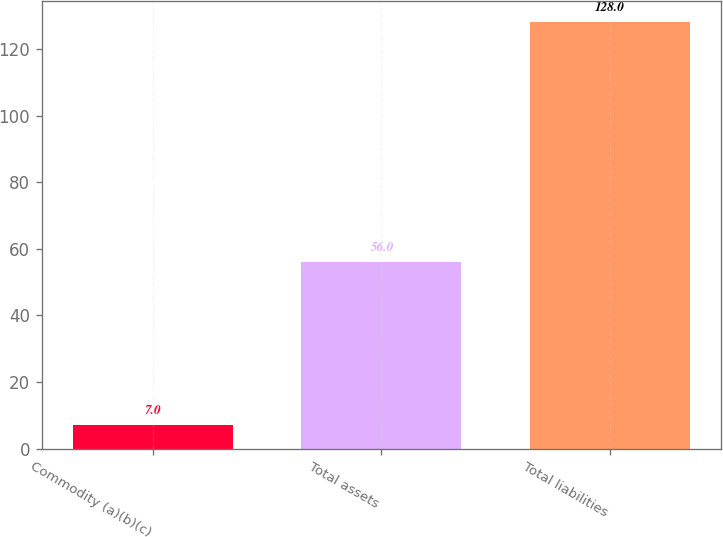<chart> <loc_0><loc_0><loc_500><loc_500><bar_chart><fcel>Commodity (a)(b)(c)<fcel>Total assets<fcel>Total liabilities<nl><fcel>7<fcel>56<fcel>128<nl></chart> 